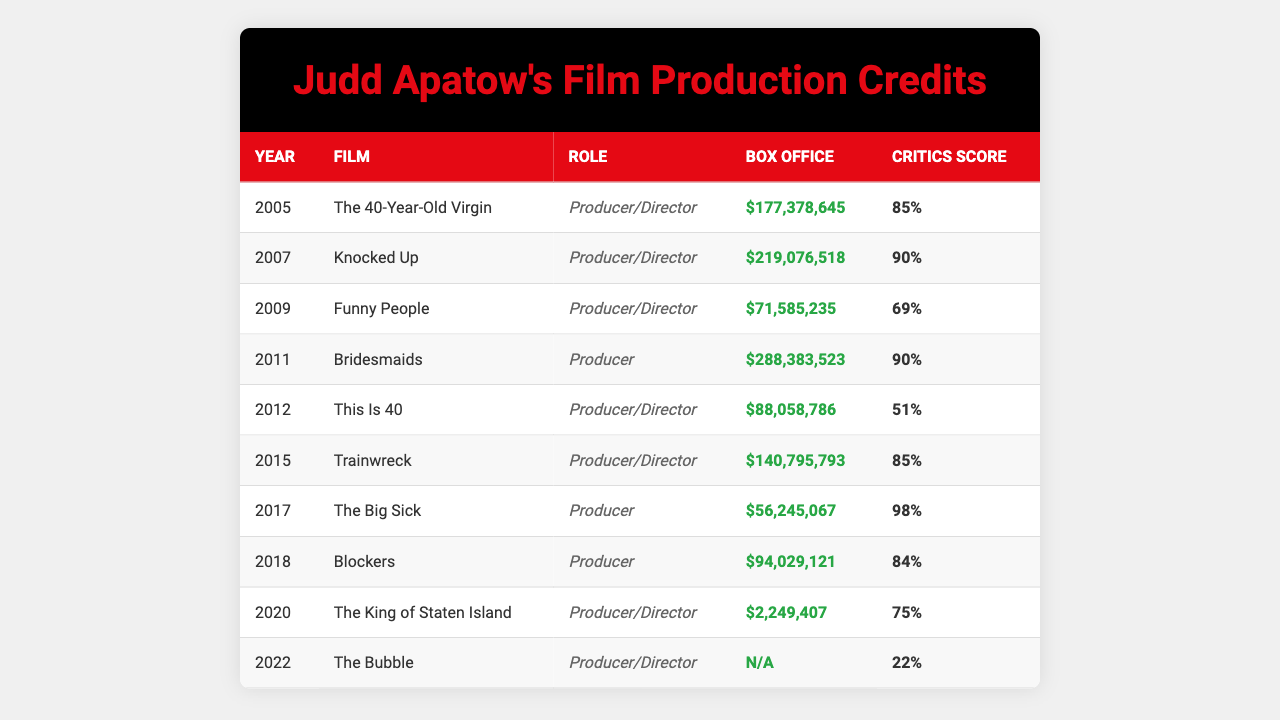What year did Judd Apatow direct "The 40-Year-Old Virgin"? The film "The 40-Year-Old Virgin" is listed in the table under the year 2005.
Answer: 2005 Which film produced by Judd Apatow has the highest critics score? By examining the critics scores in the table, "The Big Sick" has a score of 98, which is the highest compared to the other films listed.
Answer: The Big Sick What is the total box office gross of Judd Apatow's films from 2005 to 2018? To find the total box office gross, we sum the box office amounts from each film listed: $177,378,645 + $219,076,518 + $71,585,235 + $288,383,523 + $88,058,786 + $140,795,793 + $56,245,067 + $94,029,121 = $1,031,548,688.
Answer: $1,031,548,688 In which year did Judd Apatow produce a film with a box office gross of less than $10 million? From the table, the film "The King of Staten Island" in 2020 has a box office gross of only $2,249,407, and no other films show a lower box office gross that is listed.
Answer: 2020 What was the difference in box office gross between "Bridesmaids" and "Funny People"? The box office for "Bridesmaids" is $288,383,523, and for "Funny People," it is $71,585,235. The difference is calculated as $288,383,523 - $71,585,235 = $216,798,288.
Answer: $216,798,288 Did any of Judd Apatow's films released after 2015 have a critics score above 90? Looking at the table, only "The Big Sick," released in 2017, has a critics score of 98, which is above 90.
Answer: Yes What is the average critics score of all the films produced by Judd Apatow? To find the average, we sum the critics scores: 85 + 90 + 69 + 90 + 51 + 85 + 98 + 84 + 75 + 22 =  849. There are 10 films, so the average is 849 / 10 = 84.9.
Answer: 84.9 Which film had the lowest critics score and what was that score? "The Bubble" released in 2022 has the lowest critics score listed in the table at 22.
Answer: The Bubble, 22 How many films did Judd Apatow produce as a director between 2005 and 2022? By counting the listings in the table, Judd Apatow directed a total of 5 films: "The 40-Year-Old Virgin," "Knocked Up," "Funny People," "This Is 40," and "Trainwreck."
Answer: 5 